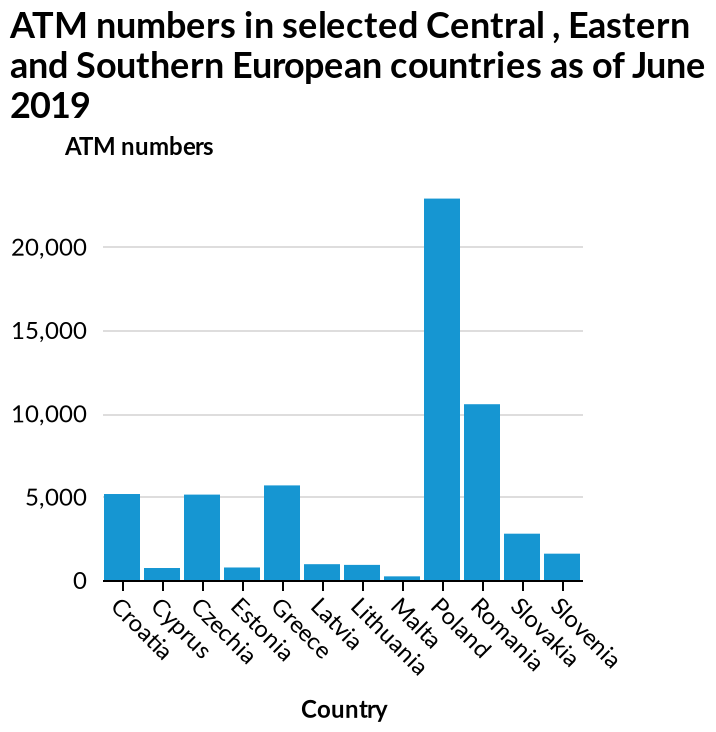<image>
please enumerates aspects of the construction of the chart ATM numbers in selected Central , Eastern and Southern European countries as of June 2019 is a bar graph. The y-axis measures ATM numbers while the x-axis measures Country. How would you describe the number of ATMs in Poland?  Poland has a huge number of ATMs. Which regions of Europe are included in the data on the bar graph? The selected Central, Eastern, and Southern European countries are included in the data on the bar graph. please summary the statistics and relations of the chart The countries with the most ATMs are Poland with approximately 22,000 and Romania with just over 10,000. Malta has the fewest with less than 1,000. Most countries have between 6,000 and 1,000 ATMs. What does the y-axis measure on the bar graph?  The y-axis measures ATM numbers. 